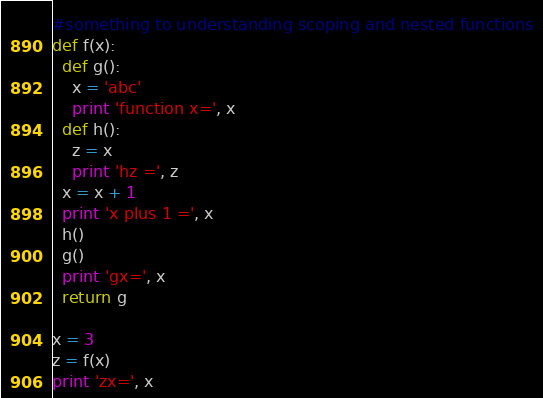Convert code to text. <code><loc_0><loc_0><loc_500><loc_500><_Python_>#something to understanding scoping and nested functions
def f(x):
  def g():
    x = 'abc'
    print 'function x=', x
  def h():
    z = x
    print 'hz =', z
  x = x + 1
  print 'x plus 1 =', x
  h()
  g()
  print 'gx=', x
  return g
 
x = 3
z = f(x)
print 'zx=', x
</code> 